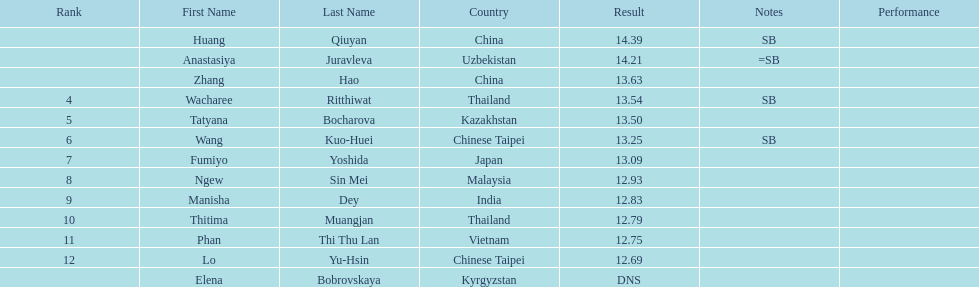What was the average result of the top three jumpers? 14.08. 